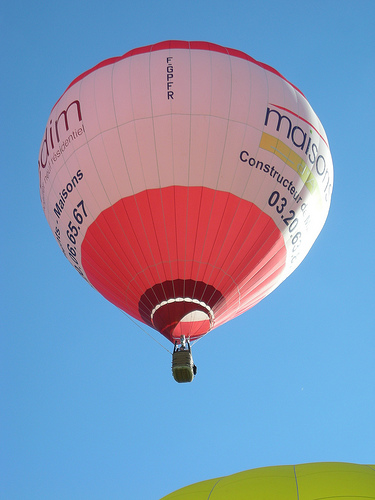<image>
Is the air balloon above the sky? No. The air balloon is not positioned above the sky. The vertical arrangement shows a different relationship. 